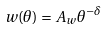Convert formula to latex. <formula><loc_0><loc_0><loc_500><loc_500>w ( \theta ) = A _ { w } \theta ^ { - \delta }</formula> 